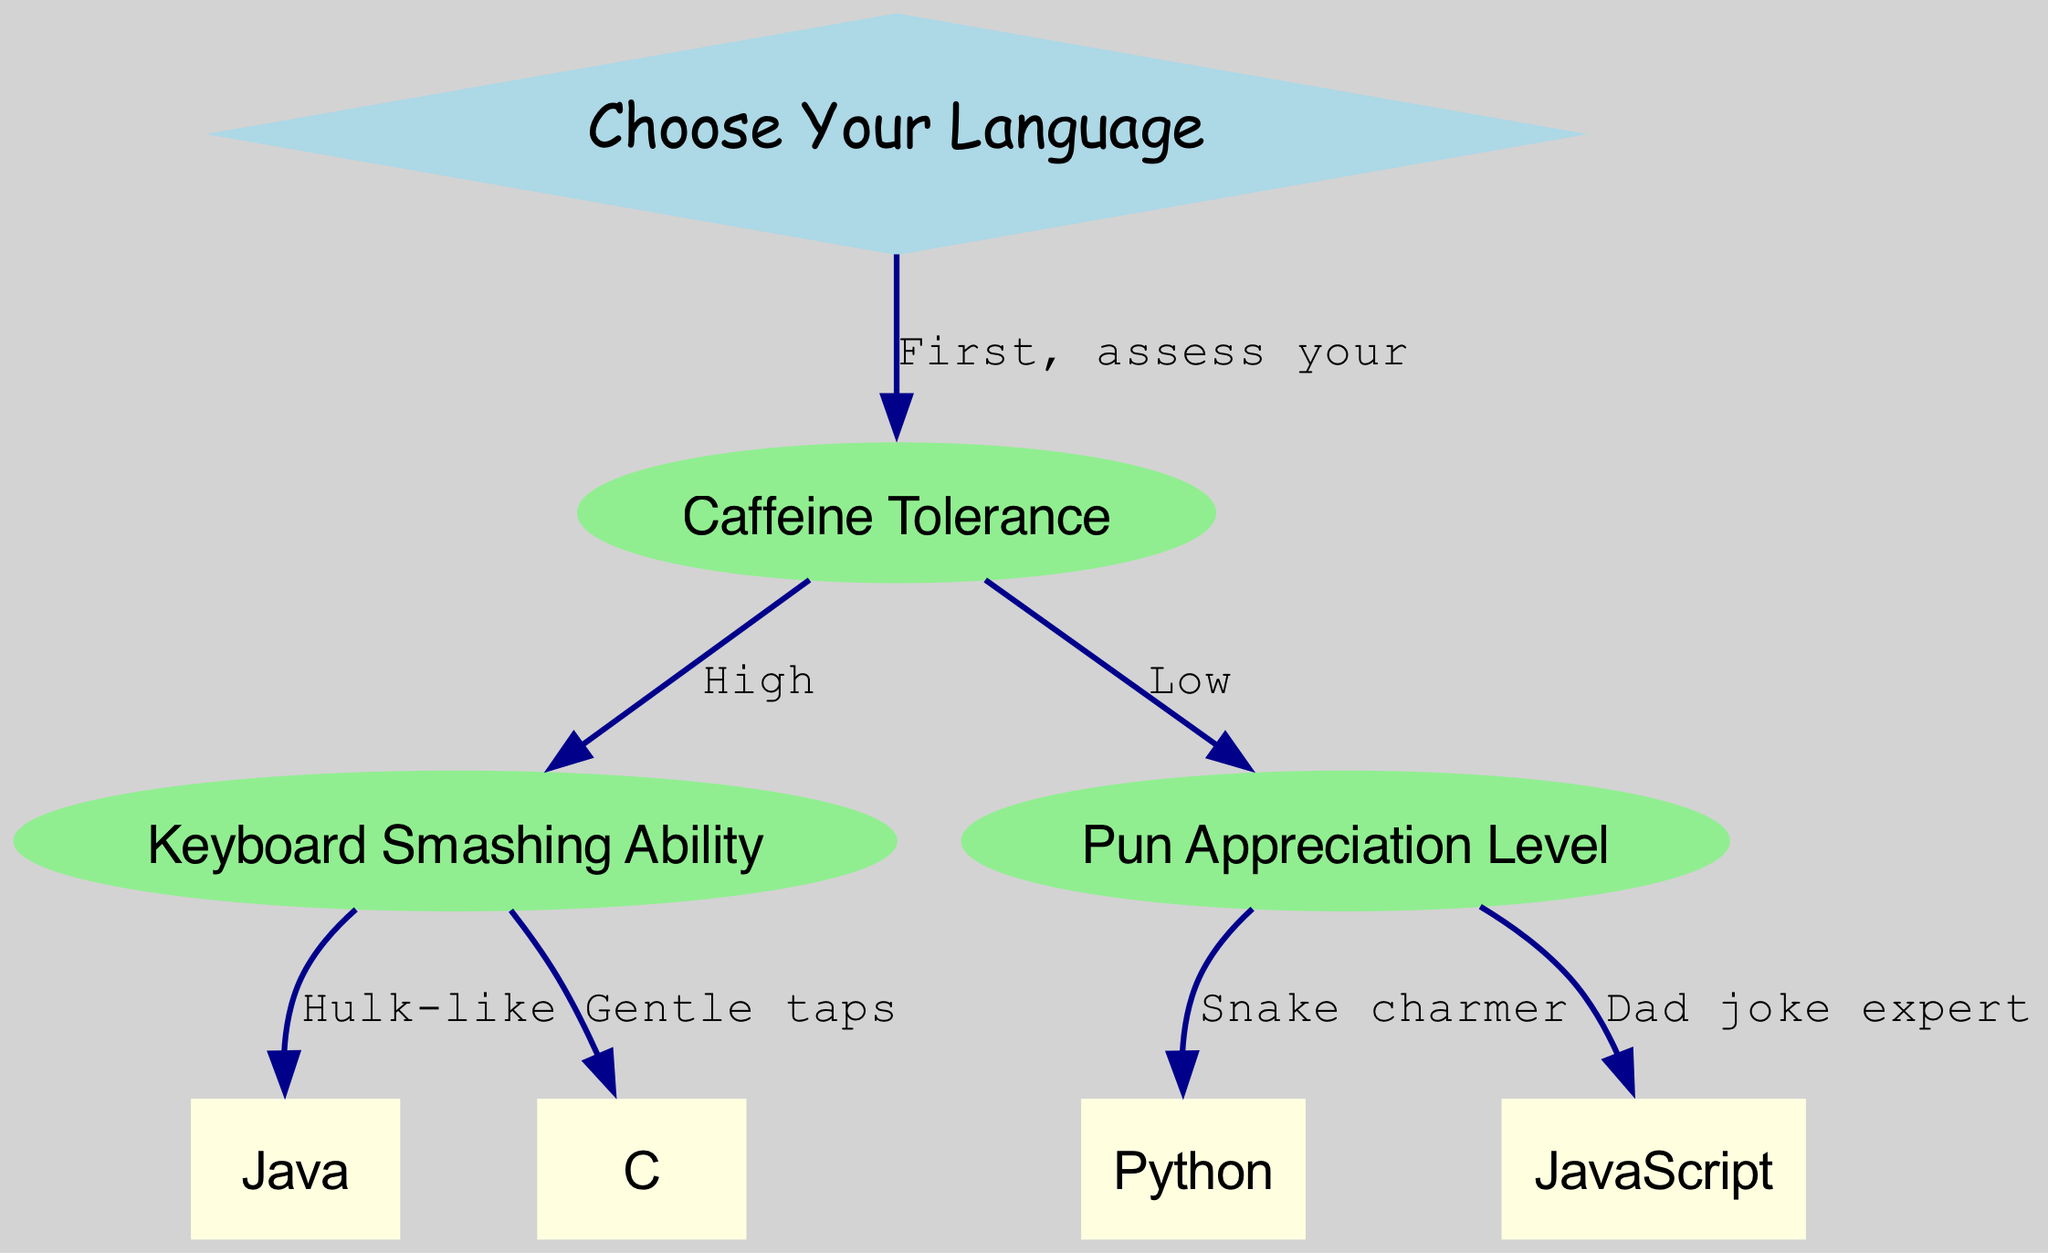What is the first step to choosing a programming language? The first step is assessing your caffeine tolerance, as indicated by the edge that leads from the "Choose Your Language" node to the "Caffeine Tolerance" node.
Answer: Assess your caffeine tolerance How many programming languages are recommended in this decision tree? There are four programming languages listed as final choices: Python, Java, JavaScript, and C, making a total of four languages.
Answer: Four If caffeine tolerance is low, which programming language should be chosen if one appreciates puns? If caffeine tolerance is low, the flow leads to the "Pun Appreciation Level" node, and if one is a snake charmer, the recommended language is Python.
Answer: Python What is the outcome if a person exhibits Hulk-like keyboard smashing ability? With Hulk-like keyboard smashing ability and high caffeine tolerance, the flow directs to Java as the outcome.
Answer: Java What does a dad joke expert recommend? A dad joke expert leads to the choice of JavaScript. This conclusion is reached by following the edge from the "Pun Appreciation Level" node to JavaScript.
Answer: JavaScript How many edges are present in the diagram? Counting the connections, there are a total of six edges connecting the nodes in the graph.
Answer: Six What node represents the assessment of keyboard smashing ability? The node for keyboard smashing ability is labeled "Keyboard Smashing Ability," which is found following the caffeine tolerance assessment.
Answer: Keyboard Smashing Ability If someone has a high caffeine tolerance but gentle taps while typing, which language should they choose? High caffeine tolerance leads to the keyboard assessment. With gentle taps indicated in that assessment, the flow directs them to C.
Answer: C 